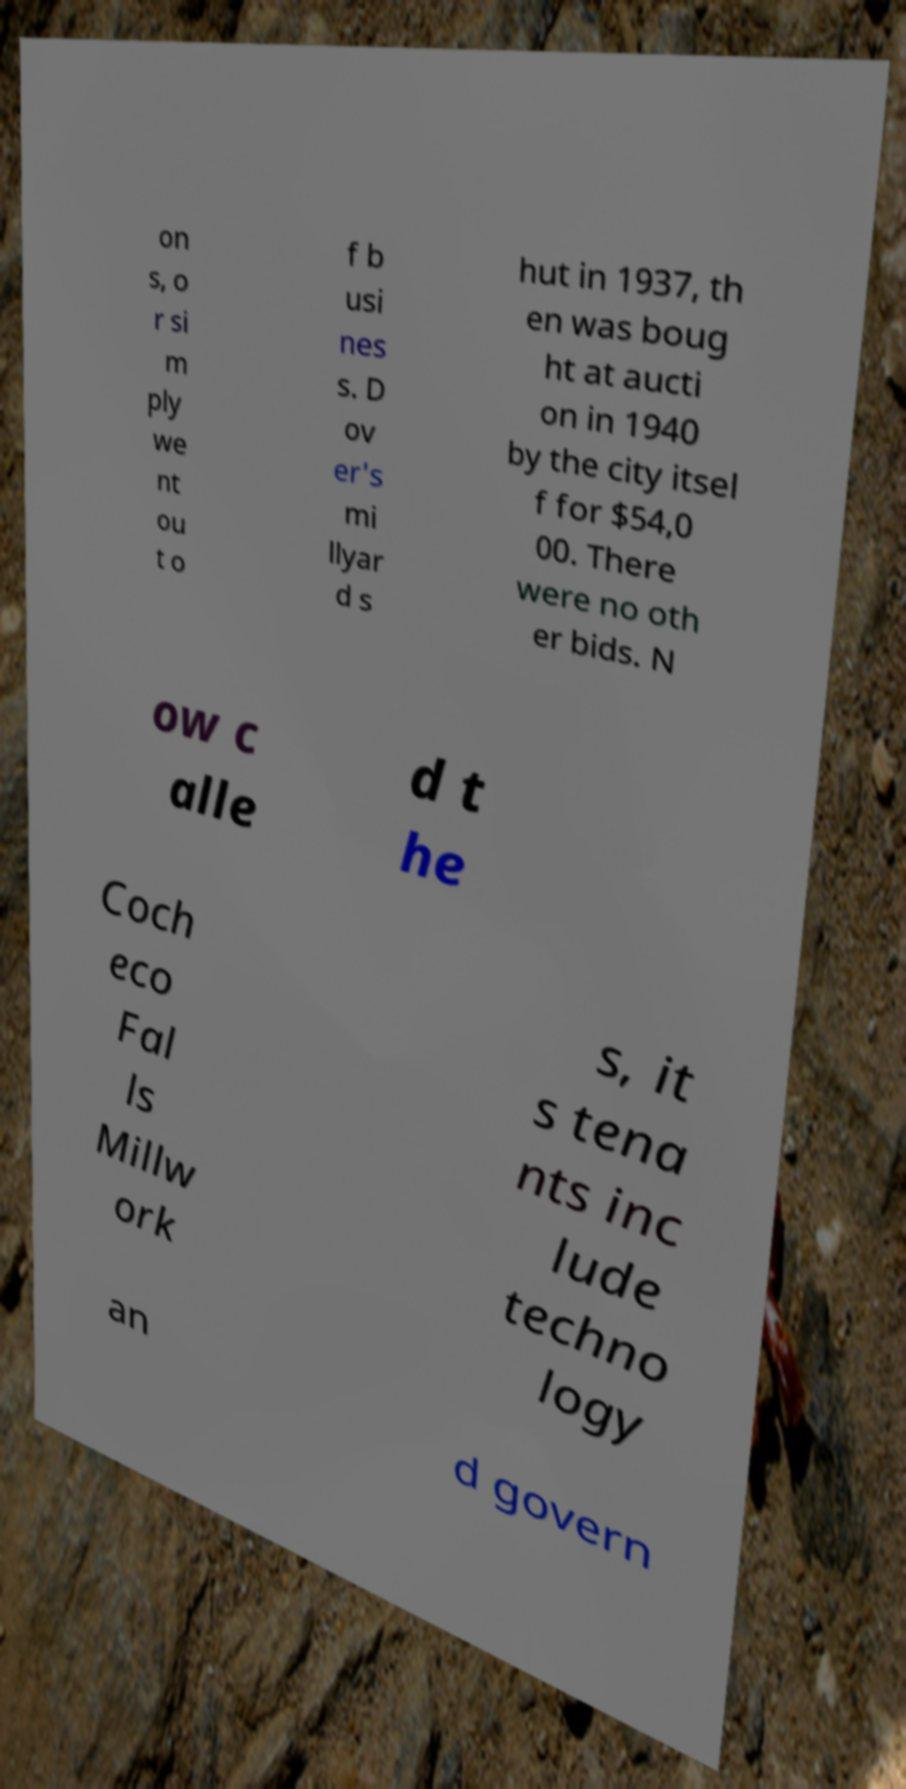Can you accurately transcribe the text from the provided image for me? on s, o r si m ply we nt ou t o f b usi nes s. D ov er's mi llyar d s hut in 1937, th en was boug ht at aucti on in 1940 by the city itsel f for $54,0 00. There were no oth er bids. N ow c alle d t he Coch eco Fal ls Millw ork s, it s tena nts inc lude techno logy an d govern 